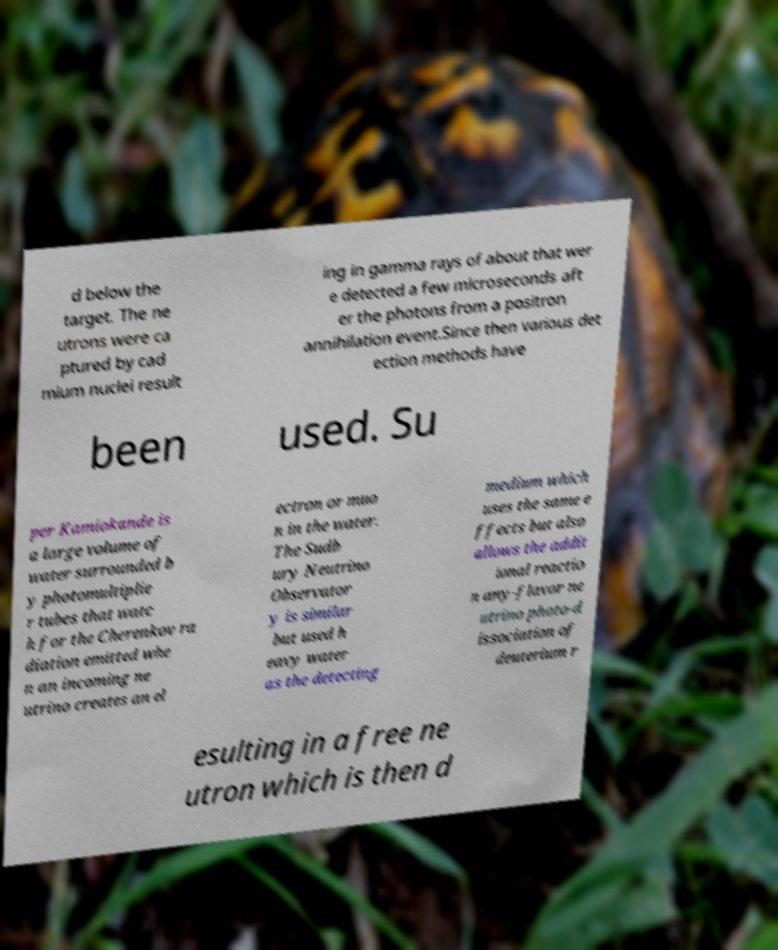For documentation purposes, I need the text within this image transcribed. Could you provide that? d below the target. The ne utrons were ca ptured by cad mium nuclei result ing in gamma rays of about that wer e detected a few microseconds aft er the photons from a positron annihilation event.Since then various det ection methods have been used. Su per Kamiokande is a large volume of water surrounded b y photomultiplie r tubes that watc h for the Cherenkov ra diation emitted whe n an incoming ne utrino creates an el ectron or muo n in the water. The Sudb ury Neutrino Observator y is similar but used h eavy water as the detecting medium which uses the same e ffects but also allows the addit ional reactio n any-flavor ne utrino photo-d issociation of deuterium r esulting in a free ne utron which is then d 